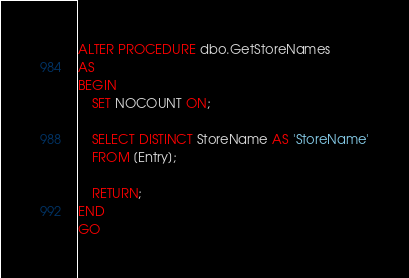<code> <loc_0><loc_0><loc_500><loc_500><_SQL_>
ALTER PROCEDURE dbo.GetStoreNames
AS
BEGIN
	SET NOCOUNT ON;
	
	SELECT DISTINCT StoreName AS 'StoreName'
	FROM [Entry];
	
	RETURN;
END
GO</code> 